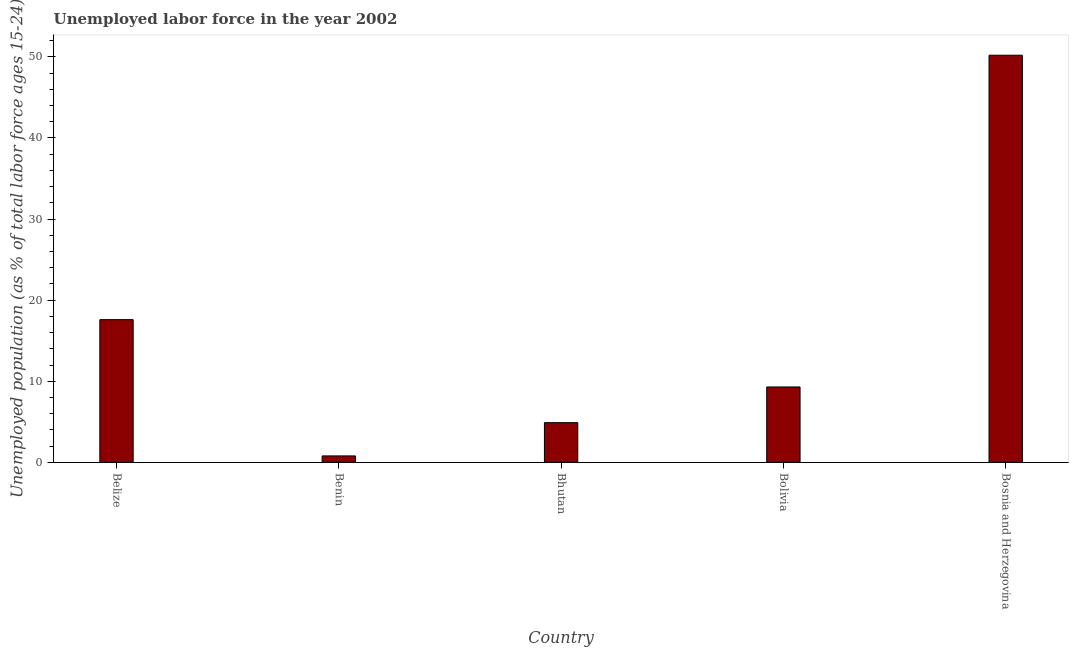What is the title of the graph?
Ensure brevity in your answer.  Unemployed labor force in the year 2002. What is the label or title of the Y-axis?
Offer a very short reply. Unemployed population (as % of total labor force ages 15-24). What is the total unemployed youth population in Belize?
Your answer should be compact. 17.6. Across all countries, what is the maximum total unemployed youth population?
Make the answer very short. 50.2. Across all countries, what is the minimum total unemployed youth population?
Provide a short and direct response. 0.8. In which country was the total unemployed youth population maximum?
Give a very brief answer. Bosnia and Herzegovina. In which country was the total unemployed youth population minimum?
Offer a terse response. Benin. What is the sum of the total unemployed youth population?
Offer a very short reply. 82.8. What is the difference between the total unemployed youth population in Belize and Bosnia and Herzegovina?
Provide a succinct answer. -32.6. What is the average total unemployed youth population per country?
Your answer should be very brief. 16.56. What is the median total unemployed youth population?
Ensure brevity in your answer.  9.3. What is the ratio of the total unemployed youth population in Benin to that in Bhutan?
Keep it short and to the point. 0.16. Is the difference between the total unemployed youth population in Bhutan and Bolivia greater than the difference between any two countries?
Provide a succinct answer. No. What is the difference between the highest and the second highest total unemployed youth population?
Ensure brevity in your answer.  32.6. Is the sum of the total unemployed youth population in Bhutan and Bolivia greater than the maximum total unemployed youth population across all countries?
Ensure brevity in your answer.  No. What is the difference between the highest and the lowest total unemployed youth population?
Offer a very short reply. 49.4. Are the values on the major ticks of Y-axis written in scientific E-notation?
Offer a very short reply. No. What is the Unemployed population (as % of total labor force ages 15-24) in Belize?
Keep it short and to the point. 17.6. What is the Unemployed population (as % of total labor force ages 15-24) of Benin?
Offer a very short reply. 0.8. What is the Unemployed population (as % of total labor force ages 15-24) in Bhutan?
Provide a succinct answer. 4.9. What is the Unemployed population (as % of total labor force ages 15-24) in Bolivia?
Your response must be concise. 9.3. What is the Unemployed population (as % of total labor force ages 15-24) of Bosnia and Herzegovina?
Provide a succinct answer. 50.2. What is the difference between the Unemployed population (as % of total labor force ages 15-24) in Belize and Benin?
Ensure brevity in your answer.  16.8. What is the difference between the Unemployed population (as % of total labor force ages 15-24) in Belize and Bhutan?
Ensure brevity in your answer.  12.7. What is the difference between the Unemployed population (as % of total labor force ages 15-24) in Belize and Bolivia?
Provide a succinct answer. 8.3. What is the difference between the Unemployed population (as % of total labor force ages 15-24) in Belize and Bosnia and Herzegovina?
Your response must be concise. -32.6. What is the difference between the Unemployed population (as % of total labor force ages 15-24) in Benin and Bolivia?
Ensure brevity in your answer.  -8.5. What is the difference between the Unemployed population (as % of total labor force ages 15-24) in Benin and Bosnia and Herzegovina?
Offer a terse response. -49.4. What is the difference between the Unemployed population (as % of total labor force ages 15-24) in Bhutan and Bosnia and Herzegovina?
Your response must be concise. -45.3. What is the difference between the Unemployed population (as % of total labor force ages 15-24) in Bolivia and Bosnia and Herzegovina?
Give a very brief answer. -40.9. What is the ratio of the Unemployed population (as % of total labor force ages 15-24) in Belize to that in Bhutan?
Provide a succinct answer. 3.59. What is the ratio of the Unemployed population (as % of total labor force ages 15-24) in Belize to that in Bolivia?
Give a very brief answer. 1.89. What is the ratio of the Unemployed population (as % of total labor force ages 15-24) in Belize to that in Bosnia and Herzegovina?
Offer a terse response. 0.35. What is the ratio of the Unemployed population (as % of total labor force ages 15-24) in Benin to that in Bhutan?
Ensure brevity in your answer.  0.16. What is the ratio of the Unemployed population (as % of total labor force ages 15-24) in Benin to that in Bolivia?
Your response must be concise. 0.09. What is the ratio of the Unemployed population (as % of total labor force ages 15-24) in Benin to that in Bosnia and Herzegovina?
Make the answer very short. 0.02. What is the ratio of the Unemployed population (as % of total labor force ages 15-24) in Bhutan to that in Bolivia?
Provide a short and direct response. 0.53. What is the ratio of the Unemployed population (as % of total labor force ages 15-24) in Bhutan to that in Bosnia and Herzegovina?
Offer a very short reply. 0.1. What is the ratio of the Unemployed population (as % of total labor force ages 15-24) in Bolivia to that in Bosnia and Herzegovina?
Offer a very short reply. 0.18. 